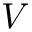<formula> <loc_0><loc_0><loc_500><loc_500>V</formula> 